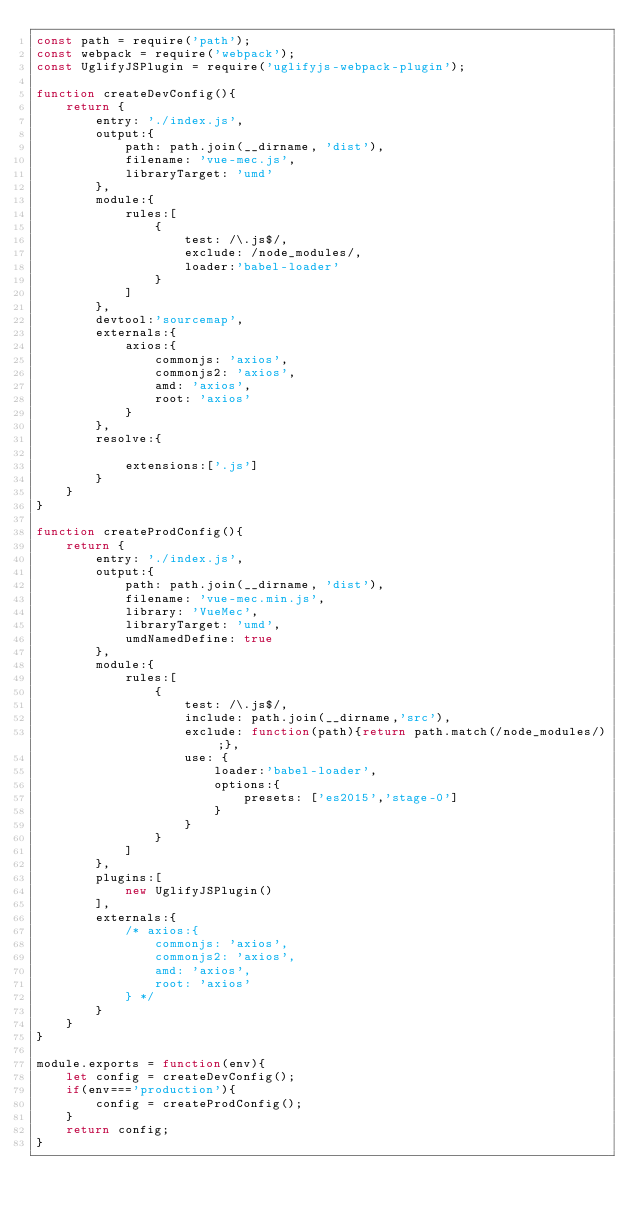Convert code to text. <code><loc_0><loc_0><loc_500><loc_500><_JavaScript_>const path = require('path');
const webpack = require('webpack');
const UglifyJSPlugin = require('uglifyjs-webpack-plugin');

function createDevConfig(){
    return {
        entry: './index.js',
        output:{
            path: path.join(__dirname, 'dist'),
            filename: 'vue-mec.js',
            libraryTarget: 'umd'
        },
        module:{
            rules:[
                {
                    test: /\.js$/,
                    exclude: /node_modules/,
                    loader:'babel-loader'
                }
            ]
        },
        devtool:'sourcemap',
        externals:{
            axios:{
                commonjs: 'axios',
                commonjs2: 'axios',
                amd: 'axios',
                root: 'axios'
            }
        },
        resolve:{
            
            extensions:['.js']
        }
    }
}

function createProdConfig(){
    return {
        entry: './index.js',
        output:{
            path: path.join(__dirname, 'dist'),
            filename: 'vue-mec.min.js',
            library: 'VueMec',
            libraryTarget: 'umd',
            umdNamedDefine: true
        },
        module:{
            rules:[
                {
                    test: /\.js$/,
                    include: path.join(__dirname,'src'), 
                    exclude: function(path){return path.match(/node_modules/);},
                    use: {
                        loader:'babel-loader',
                        options:{
                            presets: ['es2015','stage-0']
                        }
                    }
                }
            ]
        },
        plugins:[
            new UglifyJSPlugin()
        ],
        externals:{
            /* axios:{
                commonjs: 'axios',
                commonjs2: 'axios',
                amd: 'axios',
                root: 'axios'
            } */
        }
    }
}

module.exports = function(env){
	let config = createDevConfig();
	if(env==='production'){
		config = createProdConfig();
	}
	return config;
}</code> 